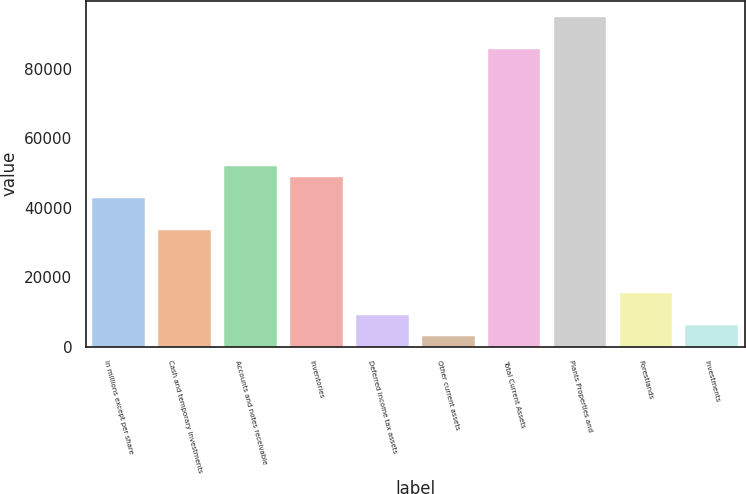Convert chart. <chart><loc_0><loc_0><loc_500><loc_500><bar_chart><fcel>In millions except per share<fcel>Cash and temporary investments<fcel>Accounts and notes receivable<fcel>Inventories<fcel>Deferred income tax assets<fcel>Other current assets<fcel>Total Current Assets<fcel>Plants Properties and<fcel>Forestlands<fcel>Investments<nl><fcel>42811.8<fcel>33643.2<fcel>51980.4<fcel>48924.2<fcel>9193.6<fcel>3081.2<fcel>85598.6<fcel>94767.2<fcel>15306<fcel>6137.4<nl></chart> 